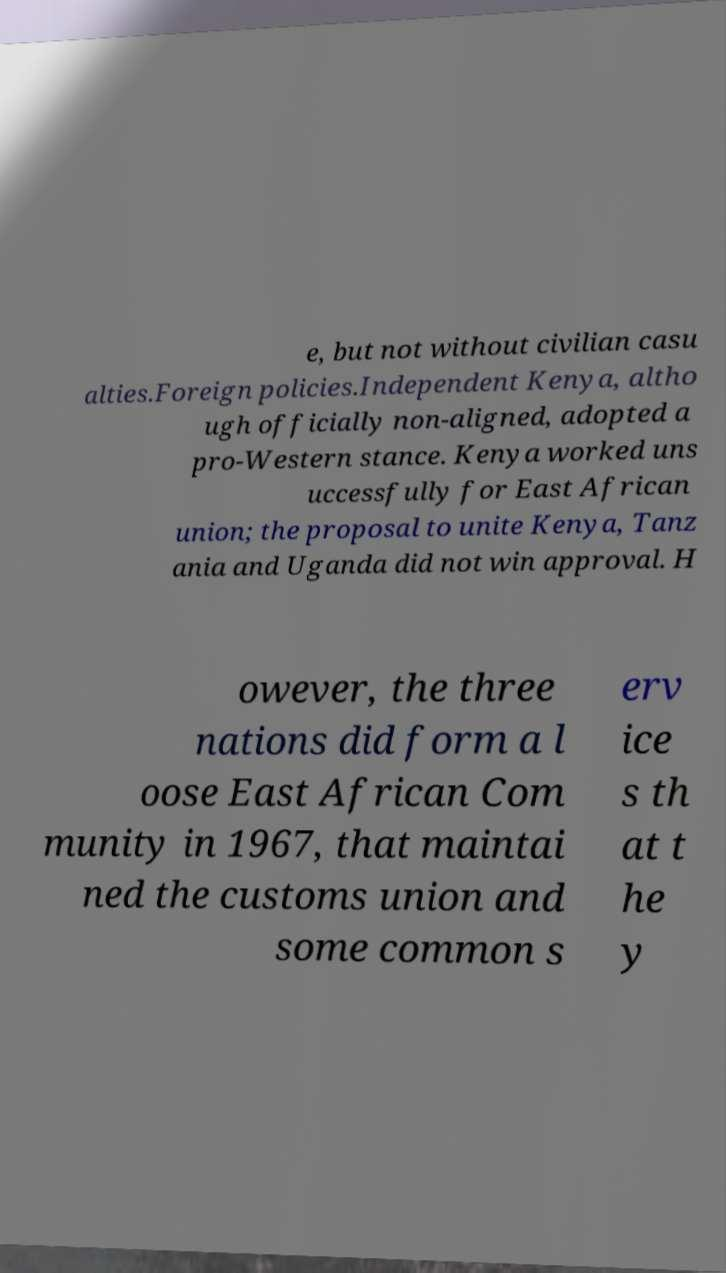For documentation purposes, I need the text within this image transcribed. Could you provide that? e, but not without civilian casu alties.Foreign policies.Independent Kenya, altho ugh officially non-aligned, adopted a pro-Western stance. Kenya worked uns uccessfully for East African union; the proposal to unite Kenya, Tanz ania and Uganda did not win approval. H owever, the three nations did form a l oose East African Com munity in 1967, that maintai ned the customs union and some common s erv ice s th at t he y 